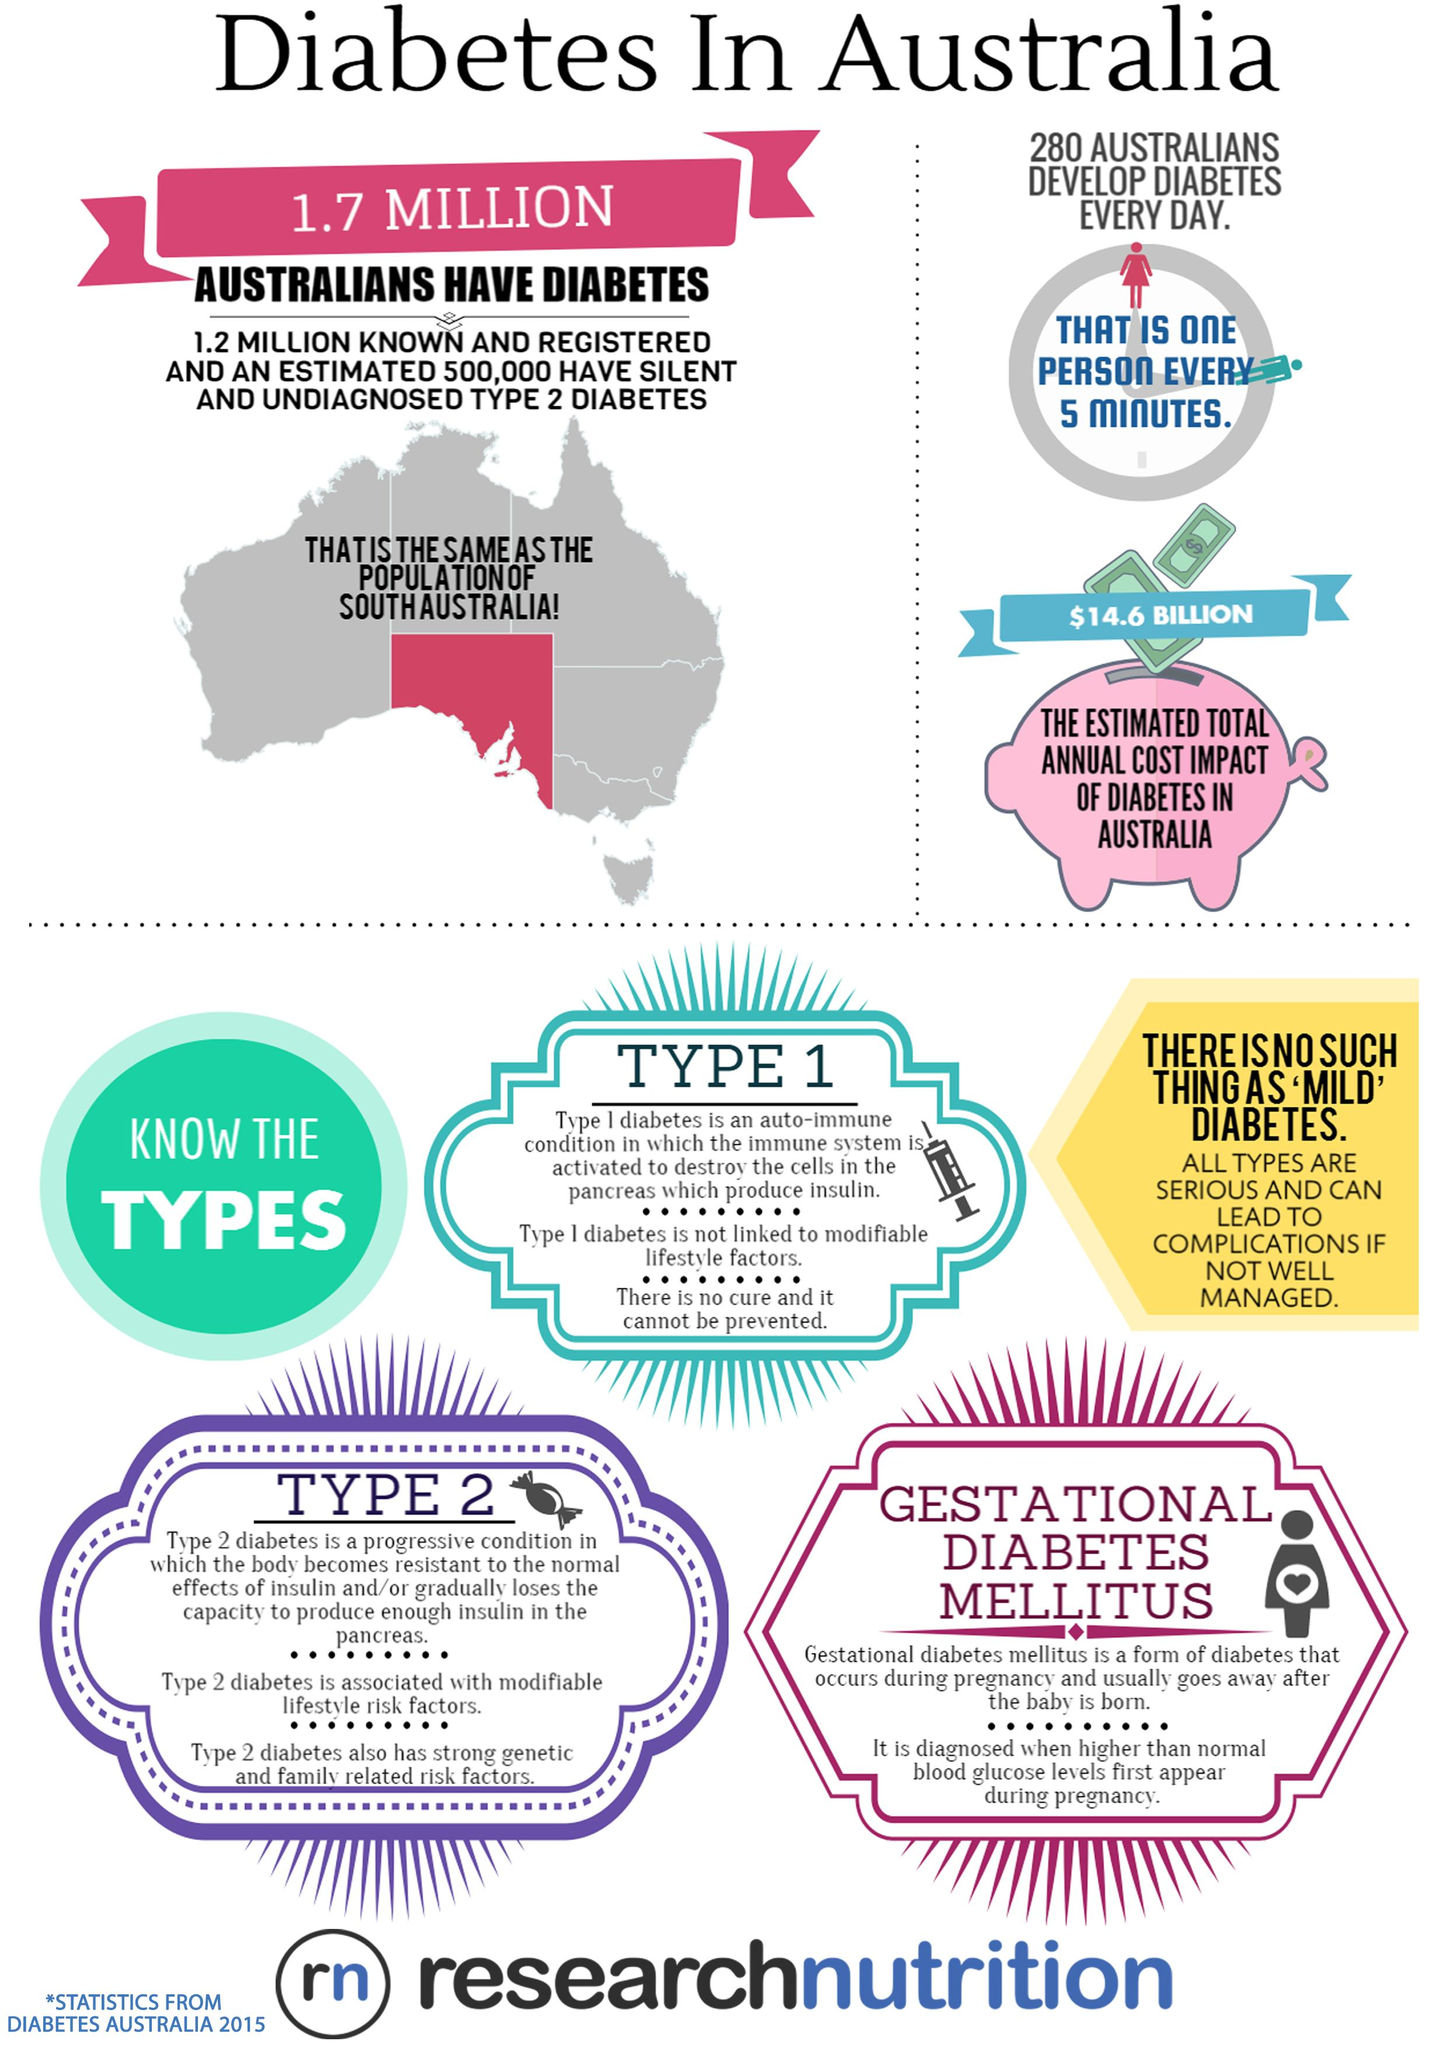List a handful of essential elements in this visual. There are three types of diabetes. 